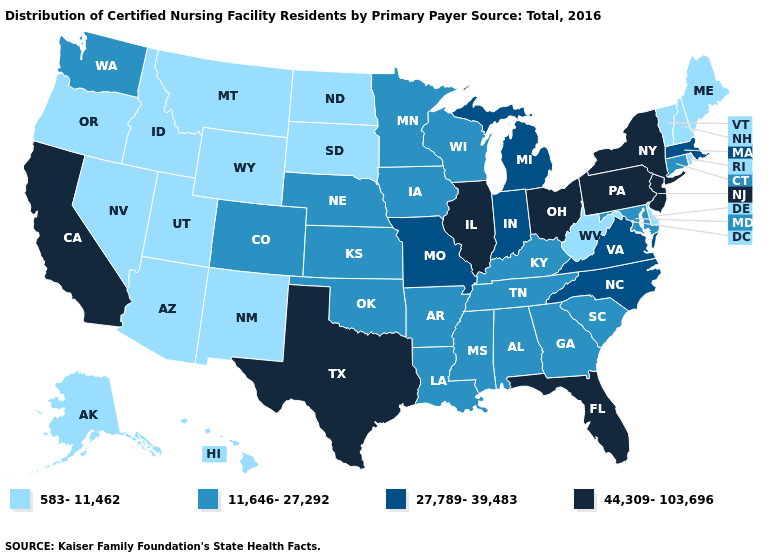What is the highest value in the West ?
Write a very short answer. 44,309-103,696. What is the value of Nebraska?
Keep it brief. 11,646-27,292. What is the value of Louisiana?
Answer briefly. 11,646-27,292. Which states hav the highest value in the Northeast?
Write a very short answer. New Jersey, New York, Pennsylvania. What is the value of North Dakota?
Be succinct. 583-11,462. What is the value of North Dakota?
Short answer required. 583-11,462. Among the states that border Arizona , does Utah have the lowest value?
Quick response, please. Yes. Does Ohio have the highest value in the MidWest?
Be succinct. Yes. Which states hav the highest value in the West?
Short answer required. California. Does the first symbol in the legend represent the smallest category?
Give a very brief answer. Yes. What is the highest value in states that border South Dakota?
Quick response, please. 11,646-27,292. Among the states that border Pennsylvania , which have the highest value?
Concise answer only. New Jersey, New York, Ohio. What is the highest value in the South ?
Be succinct. 44,309-103,696. Which states have the lowest value in the MidWest?
Write a very short answer. North Dakota, South Dakota. 